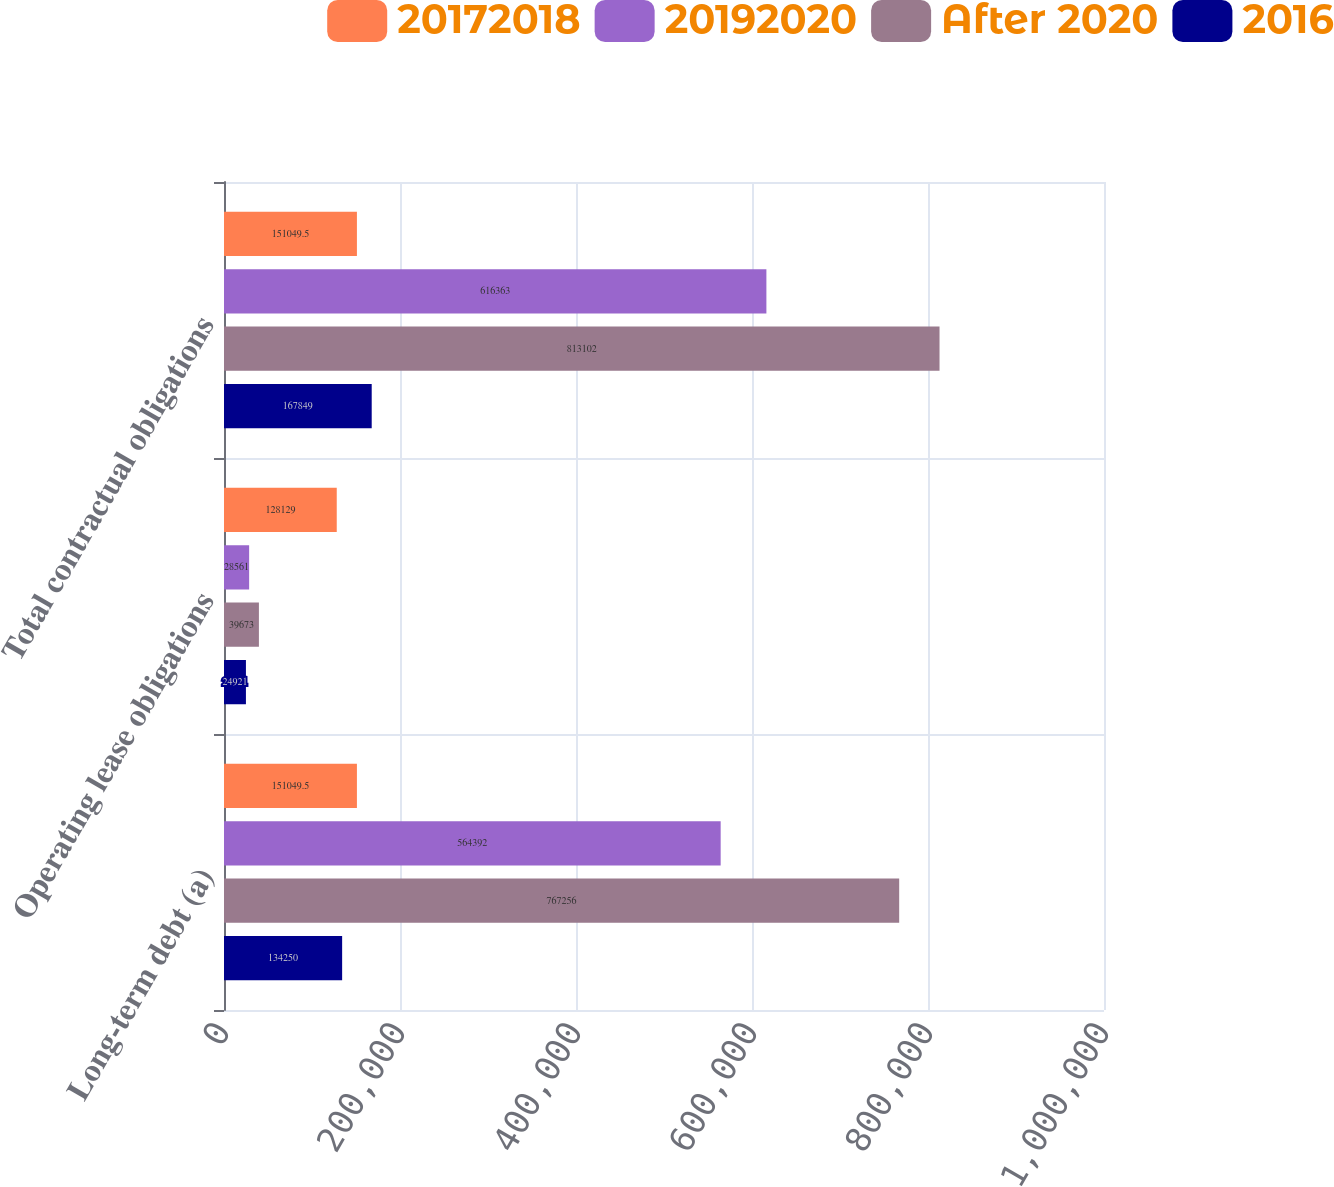<chart> <loc_0><loc_0><loc_500><loc_500><stacked_bar_chart><ecel><fcel>Long-term debt (a)<fcel>Operating lease obligations<fcel>Total contractual obligations<nl><fcel>20172018<fcel>151050<fcel>128129<fcel>151050<nl><fcel>20192020<fcel>564392<fcel>28561<fcel>616363<nl><fcel>After 2020<fcel>767256<fcel>39673<fcel>813102<nl><fcel>2016<fcel>134250<fcel>24921<fcel>167849<nl></chart> 